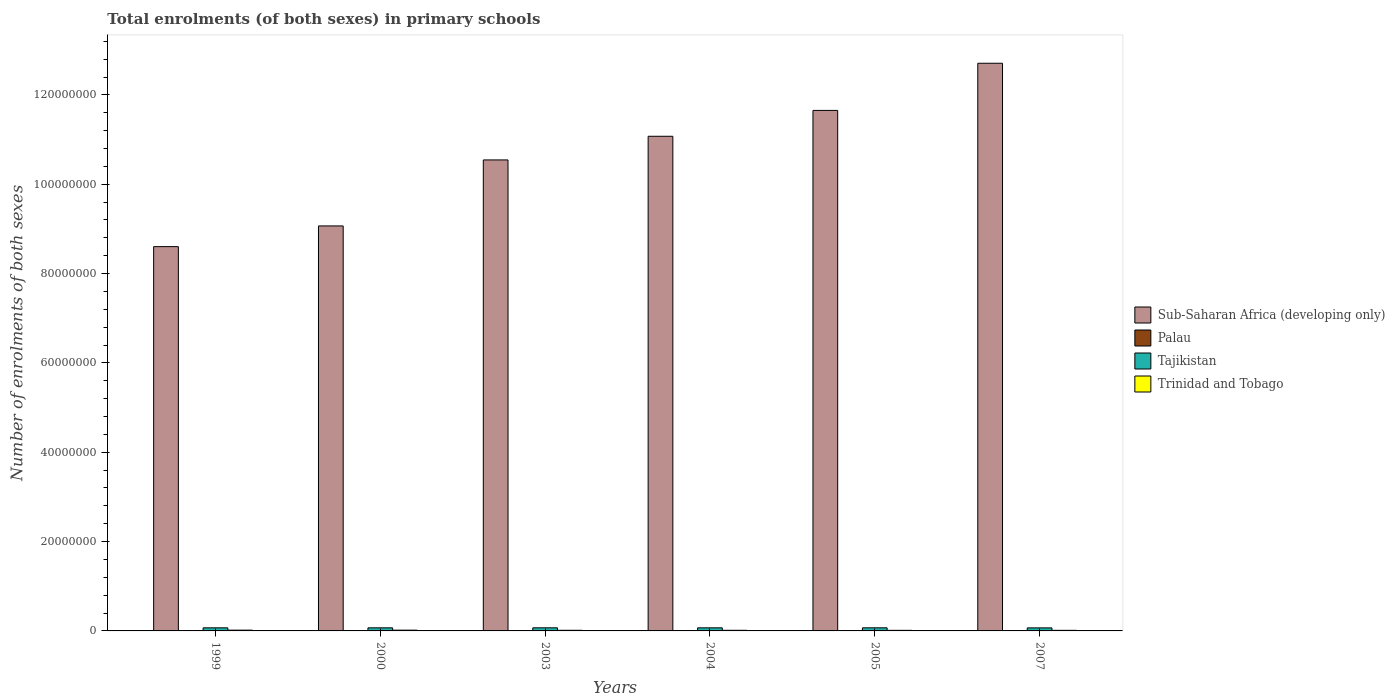How many groups of bars are there?
Provide a succinct answer. 6. Are the number of bars per tick equal to the number of legend labels?
Provide a succinct answer. Yes. Are the number of bars on each tick of the X-axis equal?
Provide a succinct answer. Yes. How many bars are there on the 5th tick from the left?
Provide a succinct answer. 4. What is the number of enrolments in primary schools in Sub-Saharan Africa (developing only) in 2005?
Offer a terse response. 1.17e+08. Across all years, what is the maximum number of enrolments in primary schools in Tajikistan?
Make the answer very short. 6.95e+05. Across all years, what is the minimum number of enrolments in primary schools in Tajikistan?
Provide a short and direct response. 6.80e+05. In which year was the number of enrolments in primary schools in Palau maximum?
Your answer should be very brief. 2003. In which year was the number of enrolments in primary schools in Trinidad and Tobago minimum?
Your answer should be compact. 2005. What is the total number of enrolments in primary schools in Sub-Saharan Africa (developing only) in the graph?
Your answer should be very brief. 6.36e+08. What is the difference between the number of enrolments in primary schools in Trinidad and Tobago in 2004 and that in 2005?
Give a very brief answer. 7610. What is the difference between the number of enrolments in primary schools in Palau in 2003 and the number of enrolments in primary schools in Tajikistan in 2004?
Provide a short and direct response. -6.88e+05. What is the average number of enrolments in primary schools in Sub-Saharan Africa (developing only) per year?
Your answer should be compact. 1.06e+08. In the year 2000, what is the difference between the number of enrolments in primary schools in Palau and number of enrolments in primary schools in Tajikistan?
Offer a very short reply. -6.90e+05. In how many years, is the number of enrolments in primary schools in Tajikistan greater than 68000000?
Ensure brevity in your answer.  0. What is the ratio of the number of enrolments in primary schools in Sub-Saharan Africa (developing only) in 2003 to that in 2007?
Your answer should be compact. 0.83. Is the difference between the number of enrolments in primary schools in Palau in 2004 and 2005 greater than the difference between the number of enrolments in primary schools in Tajikistan in 2004 and 2005?
Keep it short and to the point. Yes. What is the difference between the highest and the second highest number of enrolments in primary schools in Tajikistan?
Make the answer very short. 1852. What is the difference between the highest and the lowest number of enrolments in primary schools in Tajikistan?
Your answer should be very brief. 1.46e+04. Is it the case that in every year, the sum of the number of enrolments in primary schools in Sub-Saharan Africa (developing only) and number of enrolments in primary schools in Tajikistan is greater than the sum of number of enrolments in primary schools in Trinidad and Tobago and number of enrolments in primary schools in Palau?
Your answer should be compact. Yes. What does the 4th bar from the left in 2004 represents?
Ensure brevity in your answer.  Trinidad and Tobago. What does the 1st bar from the right in 2000 represents?
Your answer should be compact. Trinidad and Tobago. Is it the case that in every year, the sum of the number of enrolments in primary schools in Sub-Saharan Africa (developing only) and number of enrolments in primary schools in Palau is greater than the number of enrolments in primary schools in Tajikistan?
Ensure brevity in your answer.  Yes. How many years are there in the graph?
Keep it short and to the point. 6. What is the difference between two consecutive major ticks on the Y-axis?
Offer a terse response. 2.00e+07. Are the values on the major ticks of Y-axis written in scientific E-notation?
Give a very brief answer. No. Does the graph contain any zero values?
Ensure brevity in your answer.  No. Where does the legend appear in the graph?
Give a very brief answer. Center right. What is the title of the graph?
Ensure brevity in your answer.  Total enrolments (of both sexes) in primary schools. What is the label or title of the X-axis?
Your answer should be very brief. Years. What is the label or title of the Y-axis?
Provide a short and direct response. Number of enrolments of both sexes. What is the Number of enrolments of both sexes in Sub-Saharan Africa (developing only) in 1999?
Give a very brief answer. 8.60e+07. What is the Number of enrolments of both sexes in Palau in 1999?
Your answer should be compact. 1901. What is the Number of enrolments of both sexes in Tajikistan in 1999?
Give a very brief answer. 6.90e+05. What is the Number of enrolments of both sexes of Trinidad and Tobago in 1999?
Provide a succinct answer. 1.72e+05. What is the Number of enrolments of both sexes in Sub-Saharan Africa (developing only) in 2000?
Offer a terse response. 9.07e+07. What is the Number of enrolments of both sexes in Palau in 2000?
Your answer should be very brief. 1942. What is the Number of enrolments of both sexes of Tajikistan in 2000?
Your response must be concise. 6.92e+05. What is the Number of enrolments of both sexes in Trinidad and Tobago in 2000?
Your response must be concise. 1.69e+05. What is the Number of enrolments of both sexes in Sub-Saharan Africa (developing only) in 2003?
Your answer should be compact. 1.05e+08. What is the Number of enrolments of both sexes of Palau in 2003?
Provide a short and direct response. 1985. What is the Number of enrolments of both sexes in Tajikistan in 2003?
Offer a very short reply. 6.95e+05. What is the Number of enrolments of both sexes of Trinidad and Tobago in 2003?
Your answer should be compact. 1.41e+05. What is the Number of enrolments of both sexes in Sub-Saharan Africa (developing only) in 2004?
Provide a succinct answer. 1.11e+08. What is the Number of enrolments of both sexes in Palau in 2004?
Give a very brief answer. 1855. What is the Number of enrolments of both sexes in Tajikistan in 2004?
Your answer should be very brief. 6.90e+05. What is the Number of enrolments of both sexes in Trinidad and Tobago in 2004?
Offer a very short reply. 1.37e+05. What is the Number of enrolments of both sexes of Sub-Saharan Africa (developing only) in 2005?
Your answer should be compact. 1.17e+08. What is the Number of enrolments of both sexes of Palau in 2005?
Keep it short and to the point. 1805. What is the Number of enrolments of both sexes of Tajikistan in 2005?
Provide a succinct answer. 6.93e+05. What is the Number of enrolments of both sexes in Trinidad and Tobago in 2005?
Keep it short and to the point. 1.30e+05. What is the Number of enrolments of both sexes in Sub-Saharan Africa (developing only) in 2007?
Provide a succinct answer. 1.27e+08. What is the Number of enrolments of both sexes in Palau in 2007?
Keep it short and to the point. 1544. What is the Number of enrolments of both sexes in Tajikistan in 2007?
Offer a very short reply. 6.80e+05. What is the Number of enrolments of both sexes of Trinidad and Tobago in 2007?
Give a very brief answer. 1.30e+05. Across all years, what is the maximum Number of enrolments of both sexes in Sub-Saharan Africa (developing only)?
Your answer should be compact. 1.27e+08. Across all years, what is the maximum Number of enrolments of both sexes in Palau?
Provide a succinct answer. 1985. Across all years, what is the maximum Number of enrolments of both sexes of Tajikistan?
Make the answer very short. 6.95e+05. Across all years, what is the maximum Number of enrolments of both sexes of Trinidad and Tobago?
Give a very brief answer. 1.72e+05. Across all years, what is the minimum Number of enrolments of both sexes in Sub-Saharan Africa (developing only)?
Your response must be concise. 8.60e+07. Across all years, what is the minimum Number of enrolments of both sexes in Palau?
Your response must be concise. 1544. Across all years, what is the minimum Number of enrolments of both sexes in Tajikistan?
Make the answer very short. 6.80e+05. Across all years, what is the minimum Number of enrolments of both sexes in Trinidad and Tobago?
Your answer should be very brief. 1.30e+05. What is the total Number of enrolments of both sexes in Sub-Saharan Africa (developing only) in the graph?
Offer a very short reply. 6.36e+08. What is the total Number of enrolments of both sexes in Palau in the graph?
Offer a very short reply. 1.10e+04. What is the total Number of enrolments of both sexes of Tajikistan in the graph?
Give a very brief answer. 4.14e+06. What is the total Number of enrolments of both sexes in Trinidad and Tobago in the graph?
Ensure brevity in your answer.  8.79e+05. What is the difference between the Number of enrolments of both sexes of Sub-Saharan Africa (developing only) in 1999 and that in 2000?
Make the answer very short. -4.64e+06. What is the difference between the Number of enrolments of both sexes of Palau in 1999 and that in 2000?
Provide a succinct answer. -41. What is the difference between the Number of enrolments of both sexes of Tajikistan in 1999 and that in 2000?
Ensure brevity in your answer.  -1585. What is the difference between the Number of enrolments of both sexes in Trinidad and Tobago in 1999 and that in 2000?
Provide a short and direct response. 3672. What is the difference between the Number of enrolments of both sexes of Sub-Saharan Africa (developing only) in 1999 and that in 2003?
Make the answer very short. -1.94e+07. What is the difference between the Number of enrolments of both sexes in Palau in 1999 and that in 2003?
Make the answer very short. -84. What is the difference between the Number of enrolments of both sexes in Tajikistan in 1999 and that in 2003?
Provide a short and direct response. -4624. What is the difference between the Number of enrolments of both sexes of Trinidad and Tobago in 1999 and that in 2003?
Give a very brief answer. 3.12e+04. What is the difference between the Number of enrolments of both sexes in Sub-Saharan Africa (developing only) in 1999 and that in 2004?
Ensure brevity in your answer.  -2.47e+07. What is the difference between the Number of enrolments of both sexes in Palau in 1999 and that in 2004?
Provide a succinct answer. 46. What is the difference between the Number of enrolments of both sexes of Trinidad and Tobago in 1999 and that in 2004?
Your response must be concise. 3.49e+04. What is the difference between the Number of enrolments of both sexes in Sub-Saharan Africa (developing only) in 1999 and that in 2005?
Provide a succinct answer. -3.05e+07. What is the difference between the Number of enrolments of both sexes in Palau in 1999 and that in 2005?
Keep it short and to the point. 96. What is the difference between the Number of enrolments of both sexes of Tajikistan in 1999 and that in 2005?
Offer a terse response. -2772. What is the difference between the Number of enrolments of both sexes in Trinidad and Tobago in 1999 and that in 2005?
Offer a very short reply. 4.25e+04. What is the difference between the Number of enrolments of both sexes of Sub-Saharan Africa (developing only) in 1999 and that in 2007?
Keep it short and to the point. -4.11e+07. What is the difference between the Number of enrolments of both sexes in Palau in 1999 and that in 2007?
Give a very brief answer. 357. What is the difference between the Number of enrolments of both sexes in Tajikistan in 1999 and that in 2007?
Provide a succinct answer. 9998. What is the difference between the Number of enrolments of both sexes of Trinidad and Tobago in 1999 and that in 2007?
Ensure brevity in your answer.  4.20e+04. What is the difference between the Number of enrolments of both sexes in Sub-Saharan Africa (developing only) in 2000 and that in 2003?
Make the answer very short. -1.48e+07. What is the difference between the Number of enrolments of both sexes in Palau in 2000 and that in 2003?
Offer a very short reply. -43. What is the difference between the Number of enrolments of both sexes of Tajikistan in 2000 and that in 2003?
Provide a short and direct response. -3039. What is the difference between the Number of enrolments of both sexes of Trinidad and Tobago in 2000 and that in 2003?
Keep it short and to the point. 2.75e+04. What is the difference between the Number of enrolments of both sexes in Sub-Saharan Africa (developing only) in 2000 and that in 2004?
Make the answer very short. -2.01e+07. What is the difference between the Number of enrolments of both sexes in Tajikistan in 2000 and that in 2004?
Provide a short and direct response. 1621. What is the difference between the Number of enrolments of both sexes of Trinidad and Tobago in 2000 and that in 2004?
Your answer should be compact. 3.12e+04. What is the difference between the Number of enrolments of both sexes in Sub-Saharan Africa (developing only) in 2000 and that in 2005?
Your answer should be compact. -2.59e+07. What is the difference between the Number of enrolments of both sexes in Palau in 2000 and that in 2005?
Provide a short and direct response. 137. What is the difference between the Number of enrolments of both sexes in Tajikistan in 2000 and that in 2005?
Provide a short and direct response. -1187. What is the difference between the Number of enrolments of both sexes in Trinidad and Tobago in 2000 and that in 2005?
Your response must be concise. 3.88e+04. What is the difference between the Number of enrolments of both sexes of Sub-Saharan Africa (developing only) in 2000 and that in 2007?
Provide a short and direct response. -3.64e+07. What is the difference between the Number of enrolments of both sexes of Palau in 2000 and that in 2007?
Your answer should be very brief. 398. What is the difference between the Number of enrolments of both sexes in Tajikistan in 2000 and that in 2007?
Provide a succinct answer. 1.16e+04. What is the difference between the Number of enrolments of both sexes of Trinidad and Tobago in 2000 and that in 2007?
Offer a very short reply. 3.83e+04. What is the difference between the Number of enrolments of both sexes of Sub-Saharan Africa (developing only) in 2003 and that in 2004?
Your response must be concise. -5.30e+06. What is the difference between the Number of enrolments of both sexes of Palau in 2003 and that in 2004?
Keep it short and to the point. 130. What is the difference between the Number of enrolments of both sexes of Tajikistan in 2003 and that in 2004?
Make the answer very short. 4660. What is the difference between the Number of enrolments of both sexes in Trinidad and Tobago in 2003 and that in 2004?
Your answer should be very brief. 3723. What is the difference between the Number of enrolments of both sexes in Sub-Saharan Africa (developing only) in 2003 and that in 2005?
Keep it short and to the point. -1.11e+07. What is the difference between the Number of enrolments of both sexes in Palau in 2003 and that in 2005?
Provide a short and direct response. 180. What is the difference between the Number of enrolments of both sexes of Tajikistan in 2003 and that in 2005?
Keep it short and to the point. 1852. What is the difference between the Number of enrolments of both sexes of Trinidad and Tobago in 2003 and that in 2005?
Offer a terse response. 1.13e+04. What is the difference between the Number of enrolments of both sexes in Sub-Saharan Africa (developing only) in 2003 and that in 2007?
Keep it short and to the point. -2.16e+07. What is the difference between the Number of enrolments of both sexes of Palau in 2003 and that in 2007?
Ensure brevity in your answer.  441. What is the difference between the Number of enrolments of both sexes in Tajikistan in 2003 and that in 2007?
Keep it short and to the point. 1.46e+04. What is the difference between the Number of enrolments of both sexes of Trinidad and Tobago in 2003 and that in 2007?
Provide a short and direct response. 1.08e+04. What is the difference between the Number of enrolments of both sexes of Sub-Saharan Africa (developing only) in 2004 and that in 2005?
Your answer should be compact. -5.79e+06. What is the difference between the Number of enrolments of both sexes in Palau in 2004 and that in 2005?
Provide a short and direct response. 50. What is the difference between the Number of enrolments of both sexes in Tajikistan in 2004 and that in 2005?
Give a very brief answer. -2808. What is the difference between the Number of enrolments of both sexes in Trinidad and Tobago in 2004 and that in 2005?
Offer a very short reply. 7610. What is the difference between the Number of enrolments of both sexes of Sub-Saharan Africa (developing only) in 2004 and that in 2007?
Make the answer very short. -1.63e+07. What is the difference between the Number of enrolments of both sexes in Palau in 2004 and that in 2007?
Keep it short and to the point. 311. What is the difference between the Number of enrolments of both sexes of Tajikistan in 2004 and that in 2007?
Provide a succinct answer. 9962. What is the difference between the Number of enrolments of both sexes of Trinidad and Tobago in 2004 and that in 2007?
Make the answer very short. 7071. What is the difference between the Number of enrolments of both sexes in Sub-Saharan Africa (developing only) in 2005 and that in 2007?
Make the answer very short. -1.06e+07. What is the difference between the Number of enrolments of both sexes in Palau in 2005 and that in 2007?
Provide a short and direct response. 261. What is the difference between the Number of enrolments of both sexes in Tajikistan in 2005 and that in 2007?
Give a very brief answer. 1.28e+04. What is the difference between the Number of enrolments of both sexes in Trinidad and Tobago in 2005 and that in 2007?
Your response must be concise. -539. What is the difference between the Number of enrolments of both sexes in Sub-Saharan Africa (developing only) in 1999 and the Number of enrolments of both sexes in Palau in 2000?
Your response must be concise. 8.60e+07. What is the difference between the Number of enrolments of both sexes in Sub-Saharan Africa (developing only) in 1999 and the Number of enrolments of both sexes in Tajikistan in 2000?
Keep it short and to the point. 8.53e+07. What is the difference between the Number of enrolments of both sexes of Sub-Saharan Africa (developing only) in 1999 and the Number of enrolments of both sexes of Trinidad and Tobago in 2000?
Ensure brevity in your answer.  8.59e+07. What is the difference between the Number of enrolments of both sexes of Palau in 1999 and the Number of enrolments of both sexes of Tajikistan in 2000?
Provide a succinct answer. -6.90e+05. What is the difference between the Number of enrolments of both sexes of Palau in 1999 and the Number of enrolments of both sexes of Trinidad and Tobago in 2000?
Make the answer very short. -1.67e+05. What is the difference between the Number of enrolments of both sexes in Tajikistan in 1999 and the Number of enrolments of both sexes in Trinidad and Tobago in 2000?
Your answer should be compact. 5.22e+05. What is the difference between the Number of enrolments of both sexes in Sub-Saharan Africa (developing only) in 1999 and the Number of enrolments of both sexes in Palau in 2003?
Your answer should be compact. 8.60e+07. What is the difference between the Number of enrolments of both sexes of Sub-Saharan Africa (developing only) in 1999 and the Number of enrolments of both sexes of Tajikistan in 2003?
Give a very brief answer. 8.53e+07. What is the difference between the Number of enrolments of both sexes in Sub-Saharan Africa (developing only) in 1999 and the Number of enrolments of both sexes in Trinidad and Tobago in 2003?
Your answer should be very brief. 8.59e+07. What is the difference between the Number of enrolments of both sexes of Palau in 1999 and the Number of enrolments of both sexes of Tajikistan in 2003?
Your response must be concise. -6.93e+05. What is the difference between the Number of enrolments of both sexes of Palau in 1999 and the Number of enrolments of both sexes of Trinidad and Tobago in 2003?
Offer a very short reply. -1.39e+05. What is the difference between the Number of enrolments of both sexes in Tajikistan in 1999 and the Number of enrolments of both sexes in Trinidad and Tobago in 2003?
Provide a short and direct response. 5.49e+05. What is the difference between the Number of enrolments of both sexes in Sub-Saharan Africa (developing only) in 1999 and the Number of enrolments of both sexes in Palau in 2004?
Offer a terse response. 8.60e+07. What is the difference between the Number of enrolments of both sexes in Sub-Saharan Africa (developing only) in 1999 and the Number of enrolments of both sexes in Tajikistan in 2004?
Ensure brevity in your answer.  8.53e+07. What is the difference between the Number of enrolments of both sexes in Sub-Saharan Africa (developing only) in 1999 and the Number of enrolments of both sexes in Trinidad and Tobago in 2004?
Ensure brevity in your answer.  8.59e+07. What is the difference between the Number of enrolments of both sexes in Palau in 1999 and the Number of enrolments of both sexes in Tajikistan in 2004?
Keep it short and to the point. -6.88e+05. What is the difference between the Number of enrolments of both sexes in Palau in 1999 and the Number of enrolments of both sexes in Trinidad and Tobago in 2004?
Give a very brief answer. -1.35e+05. What is the difference between the Number of enrolments of both sexes in Tajikistan in 1999 and the Number of enrolments of both sexes in Trinidad and Tobago in 2004?
Keep it short and to the point. 5.53e+05. What is the difference between the Number of enrolments of both sexes of Sub-Saharan Africa (developing only) in 1999 and the Number of enrolments of both sexes of Palau in 2005?
Offer a very short reply. 8.60e+07. What is the difference between the Number of enrolments of both sexes of Sub-Saharan Africa (developing only) in 1999 and the Number of enrolments of both sexes of Tajikistan in 2005?
Provide a short and direct response. 8.53e+07. What is the difference between the Number of enrolments of both sexes of Sub-Saharan Africa (developing only) in 1999 and the Number of enrolments of both sexes of Trinidad and Tobago in 2005?
Your response must be concise. 8.59e+07. What is the difference between the Number of enrolments of both sexes in Palau in 1999 and the Number of enrolments of both sexes in Tajikistan in 2005?
Offer a terse response. -6.91e+05. What is the difference between the Number of enrolments of both sexes in Palau in 1999 and the Number of enrolments of both sexes in Trinidad and Tobago in 2005?
Provide a succinct answer. -1.28e+05. What is the difference between the Number of enrolments of both sexes of Tajikistan in 1999 and the Number of enrolments of both sexes of Trinidad and Tobago in 2005?
Offer a terse response. 5.61e+05. What is the difference between the Number of enrolments of both sexes of Sub-Saharan Africa (developing only) in 1999 and the Number of enrolments of both sexes of Palau in 2007?
Your answer should be very brief. 8.60e+07. What is the difference between the Number of enrolments of both sexes in Sub-Saharan Africa (developing only) in 1999 and the Number of enrolments of both sexes in Tajikistan in 2007?
Your answer should be compact. 8.53e+07. What is the difference between the Number of enrolments of both sexes in Sub-Saharan Africa (developing only) in 1999 and the Number of enrolments of both sexes in Trinidad and Tobago in 2007?
Keep it short and to the point. 8.59e+07. What is the difference between the Number of enrolments of both sexes in Palau in 1999 and the Number of enrolments of both sexes in Tajikistan in 2007?
Offer a terse response. -6.78e+05. What is the difference between the Number of enrolments of both sexes of Palau in 1999 and the Number of enrolments of both sexes of Trinidad and Tobago in 2007?
Provide a succinct answer. -1.28e+05. What is the difference between the Number of enrolments of both sexes of Tajikistan in 1999 and the Number of enrolments of both sexes of Trinidad and Tobago in 2007?
Keep it short and to the point. 5.60e+05. What is the difference between the Number of enrolments of both sexes in Sub-Saharan Africa (developing only) in 2000 and the Number of enrolments of both sexes in Palau in 2003?
Ensure brevity in your answer.  9.07e+07. What is the difference between the Number of enrolments of both sexes in Sub-Saharan Africa (developing only) in 2000 and the Number of enrolments of both sexes in Tajikistan in 2003?
Keep it short and to the point. 9.00e+07. What is the difference between the Number of enrolments of both sexes in Sub-Saharan Africa (developing only) in 2000 and the Number of enrolments of both sexes in Trinidad and Tobago in 2003?
Offer a terse response. 9.05e+07. What is the difference between the Number of enrolments of both sexes in Palau in 2000 and the Number of enrolments of both sexes in Tajikistan in 2003?
Offer a terse response. -6.93e+05. What is the difference between the Number of enrolments of both sexes in Palau in 2000 and the Number of enrolments of both sexes in Trinidad and Tobago in 2003?
Provide a short and direct response. -1.39e+05. What is the difference between the Number of enrolments of both sexes of Tajikistan in 2000 and the Number of enrolments of both sexes of Trinidad and Tobago in 2003?
Your response must be concise. 5.51e+05. What is the difference between the Number of enrolments of both sexes of Sub-Saharan Africa (developing only) in 2000 and the Number of enrolments of both sexes of Palau in 2004?
Provide a short and direct response. 9.07e+07. What is the difference between the Number of enrolments of both sexes of Sub-Saharan Africa (developing only) in 2000 and the Number of enrolments of both sexes of Tajikistan in 2004?
Ensure brevity in your answer.  9.00e+07. What is the difference between the Number of enrolments of both sexes in Sub-Saharan Africa (developing only) in 2000 and the Number of enrolments of both sexes in Trinidad and Tobago in 2004?
Provide a succinct answer. 9.05e+07. What is the difference between the Number of enrolments of both sexes in Palau in 2000 and the Number of enrolments of both sexes in Tajikistan in 2004?
Provide a succinct answer. -6.88e+05. What is the difference between the Number of enrolments of both sexes of Palau in 2000 and the Number of enrolments of both sexes of Trinidad and Tobago in 2004?
Offer a very short reply. -1.35e+05. What is the difference between the Number of enrolments of both sexes of Tajikistan in 2000 and the Number of enrolments of both sexes of Trinidad and Tobago in 2004?
Provide a short and direct response. 5.55e+05. What is the difference between the Number of enrolments of both sexes of Sub-Saharan Africa (developing only) in 2000 and the Number of enrolments of both sexes of Palau in 2005?
Offer a terse response. 9.07e+07. What is the difference between the Number of enrolments of both sexes of Sub-Saharan Africa (developing only) in 2000 and the Number of enrolments of both sexes of Tajikistan in 2005?
Make the answer very short. 9.00e+07. What is the difference between the Number of enrolments of both sexes of Sub-Saharan Africa (developing only) in 2000 and the Number of enrolments of both sexes of Trinidad and Tobago in 2005?
Your response must be concise. 9.05e+07. What is the difference between the Number of enrolments of both sexes of Palau in 2000 and the Number of enrolments of both sexes of Tajikistan in 2005?
Offer a terse response. -6.91e+05. What is the difference between the Number of enrolments of both sexes in Palau in 2000 and the Number of enrolments of both sexes in Trinidad and Tobago in 2005?
Your answer should be very brief. -1.28e+05. What is the difference between the Number of enrolments of both sexes in Tajikistan in 2000 and the Number of enrolments of both sexes in Trinidad and Tobago in 2005?
Offer a very short reply. 5.62e+05. What is the difference between the Number of enrolments of both sexes of Sub-Saharan Africa (developing only) in 2000 and the Number of enrolments of both sexes of Palau in 2007?
Keep it short and to the point. 9.07e+07. What is the difference between the Number of enrolments of both sexes in Sub-Saharan Africa (developing only) in 2000 and the Number of enrolments of both sexes in Tajikistan in 2007?
Your response must be concise. 9.00e+07. What is the difference between the Number of enrolments of both sexes in Sub-Saharan Africa (developing only) in 2000 and the Number of enrolments of both sexes in Trinidad and Tobago in 2007?
Your answer should be very brief. 9.05e+07. What is the difference between the Number of enrolments of both sexes in Palau in 2000 and the Number of enrolments of both sexes in Tajikistan in 2007?
Offer a terse response. -6.78e+05. What is the difference between the Number of enrolments of both sexes of Palau in 2000 and the Number of enrolments of both sexes of Trinidad and Tobago in 2007?
Keep it short and to the point. -1.28e+05. What is the difference between the Number of enrolments of both sexes in Tajikistan in 2000 and the Number of enrolments of both sexes in Trinidad and Tobago in 2007?
Keep it short and to the point. 5.62e+05. What is the difference between the Number of enrolments of both sexes of Sub-Saharan Africa (developing only) in 2003 and the Number of enrolments of both sexes of Palau in 2004?
Provide a short and direct response. 1.05e+08. What is the difference between the Number of enrolments of both sexes of Sub-Saharan Africa (developing only) in 2003 and the Number of enrolments of both sexes of Tajikistan in 2004?
Keep it short and to the point. 1.05e+08. What is the difference between the Number of enrolments of both sexes in Sub-Saharan Africa (developing only) in 2003 and the Number of enrolments of both sexes in Trinidad and Tobago in 2004?
Give a very brief answer. 1.05e+08. What is the difference between the Number of enrolments of both sexes of Palau in 2003 and the Number of enrolments of both sexes of Tajikistan in 2004?
Your answer should be compact. -6.88e+05. What is the difference between the Number of enrolments of both sexes in Palau in 2003 and the Number of enrolments of both sexes in Trinidad and Tobago in 2004?
Provide a short and direct response. -1.35e+05. What is the difference between the Number of enrolments of both sexes of Tajikistan in 2003 and the Number of enrolments of both sexes of Trinidad and Tobago in 2004?
Make the answer very short. 5.58e+05. What is the difference between the Number of enrolments of both sexes of Sub-Saharan Africa (developing only) in 2003 and the Number of enrolments of both sexes of Palau in 2005?
Give a very brief answer. 1.05e+08. What is the difference between the Number of enrolments of both sexes of Sub-Saharan Africa (developing only) in 2003 and the Number of enrolments of both sexes of Tajikistan in 2005?
Provide a succinct answer. 1.05e+08. What is the difference between the Number of enrolments of both sexes of Sub-Saharan Africa (developing only) in 2003 and the Number of enrolments of both sexes of Trinidad and Tobago in 2005?
Make the answer very short. 1.05e+08. What is the difference between the Number of enrolments of both sexes of Palau in 2003 and the Number of enrolments of both sexes of Tajikistan in 2005?
Ensure brevity in your answer.  -6.91e+05. What is the difference between the Number of enrolments of both sexes in Palau in 2003 and the Number of enrolments of both sexes in Trinidad and Tobago in 2005?
Your answer should be compact. -1.28e+05. What is the difference between the Number of enrolments of both sexes in Tajikistan in 2003 and the Number of enrolments of both sexes in Trinidad and Tobago in 2005?
Make the answer very short. 5.65e+05. What is the difference between the Number of enrolments of both sexes in Sub-Saharan Africa (developing only) in 2003 and the Number of enrolments of both sexes in Palau in 2007?
Your answer should be very brief. 1.05e+08. What is the difference between the Number of enrolments of both sexes in Sub-Saharan Africa (developing only) in 2003 and the Number of enrolments of both sexes in Tajikistan in 2007?
Keep it short and to the point. 1.05e+08. What is the difference between the Number of enrolments of both sexes of Sub-Saharan Africa (developing only) in 2003 and the Number of enrolments of both sexes of Trinidad and Tobago in 2007?
Give a very brief answer. 1.05e+08. What is the difference between the Number of enrolments of both sexes of Palau in 2003 and the Number of enrolments of both sexes of Tajikistan in 2007?
Give a very brief answer. -6.78e+05. What is the difference between the Number of enrolments of both sexes of Palau in 2003 and the Number of enrolments of both sexes of Trinidad and Tobago in 2007?
Make the answer very short. -1.28e+05. What is the difference between the Number of enrolments of both sexes of Tajikistan in 2003 and the Number of enrolments of both sexes of Trinidad and Tobago in 2007?
Your response must be concise. 5.65e+05. What is the difference between the Number of enrolments of both sexes of Sub-Saharan Africa (developing only) in 2004 and the Number of enrolments of both sexes of Palau in 2005?
Your response must be concise. 1.11e+08. What is the difference between the Number of enrolments of both sexes in Sub-Saharan Africa (developing only) in 2004 and the Number of enrolments of both sexes in Tajikistan in 2005?
Offer a very short reply. 1.10e+08. What is the difference between the Number of enrolments of both sexes of Sub-Saharan Africa (developing only) in 2004 and the Number of enrolments of both sexes of Trinidad and Tobago in 2005?
Keep it short and to the point. 1.11e+08. What is the difference between the Number of enrolments of both sexes of Palau in 2004 and the Number of enrolments of both sexes of Tajikistan in 2005?
Your answer should be compact. -6.91e+05. What is the difference between the Number of enrolments of both sexes in Palau in 2004 and the Number of enrolments of both sexes in Trinidad and Tobago in 2005?
Give a very brief answer. -1.28e+05. What is the difference between the Number of enrolments of both sexes of Tajikistan in 2004 and the Number of enrolments of both sexes of Trinidad and Tobago in 2005?
Your response must be concise. 5.61e+05. What is the difference between the Number of enrolments of both sexes in Sub-Saharan Africa (developing only) in 2004 and the Number of enrolments of both sexes in Palau in 2007?
Your answer should be compact. 1.11e+08. What is the difference between the Number of enrolments of both sexes of Sub-Saharan Africa (developing only) in 2004 and the Number of enrolments of both sexes of Tajikistan in 2007?
Offer a terse response. 1.10e+08. What is the difference between the Number of enrolments of both sexes of Sub-Saharan Africa (developing only) in 2004 and the Number of enrolments of both sexes of Trinidad and Tobago in 2007?
Provide a succinct answer. 1.11e+08. What is the difference between the Number of enrolments of both sexes in Palau in 2004 and the Number of enrolments of both sexes in Tajikistan in 2007?
Provide a short and direct response. -6.78e+05. What is the difference between the Number of enrolments of both sexes in Palau in 2004 and the Number of enrolments of both sexes in Trinidad and Tobago in 2007?
Ensure brevity in your answer.  -1.28e+05. What is the difference between the Number of enrolments of both sexes in Tajikistan in 2004 and the Number of enrolments of both sexes in Trinidad and Tobago in 2007?
Ensure brevity in your answer.  5.60e+05. What is the difference between the Number of enrolments of both sexes of Sub-Saharan Africa (developing only) in 2005 and the Number of enrolments of both sexes of Palau in 2007?
Your response must be concise. 1.17e+08. What is the difference between the Number of enrolments of both sexes in Sub-Saharan Africa (developing only) in 2005 and the Number of enrolments of both sexes in Tajikistan in 2007?
Ensure brevity in your answer.  1.16e+08. What is the difference between the Number of enrolments of both sexes in Sub-Saharan Africa (developing only) in 2005 and the Number of enrolments of both sexes in Trinidad and Tobago in 2007?
Provide a succinct answer. 1.16e+08. What is the difference between the Number of enrolments of both sexes of Palau in 2005 and the Number of enrolments of both sexes of Tajikistan in 2007?
Offer a terse response. -6.79e+05. What is the difference between the Number of enrolments of both sexes of Palau in 2005 and the Number of enrolments of both sexes of Trinidad and Tobago in 2007?
Keep it short and to the point. -1.28e+05. What is the difference between the Number of enrolments of both sexes in Tajikistan in 2005 and the Number of enrolments of both sexes in Trinidad and Tobago in 2007?
Your answer should be very brief. 5.63e+05. What is the average Number of enrolments of both sexes in Sub-Saharan Africa (developing only) per year?
Give a very brief answer. 1.06e+08. What is the average Number of enrolments of both sexes in Palau per year?
Provide a short and direct response. 1838.67. What is the average Number of enrolments of both sexes in Tajikistan per year?
Provide a succinct answer. 6.90e+05. What is the average Number of enrolments of both sexes in Trinidad and Tobago per year?
Provide a succinct answer. 1.47e+05. In the year 1999, what is the difference between the Number of enrolments of both sexes of Sub-Saharan Africa (developing only) and Number of enrolments of both sexes of Palau?
Provide a short and direct response. 8.60e+07. In the year 1999, what is the difference between the Number of enrolments of both sexes in Sub-Saharan Africa (developing only) and Number of enrolments of both sexes in Tajikistan?
Your response must be concise. 8.53e+07. In the year 1999, what is the difference between the Number of enrolments of both sexes of Sub-Saharan Africa (developing only) and Number of enrolments of both sexes of Trinidad and Tobago?
Offer a very short reply. 8.59e+07. In the year 1999, what is the difference between the Number of enrolments of both sexes of Palau and Number of enrolments of both sexes of Tajikistan?
Your answer should be very brief. -6.88e+05. In the year 1999, what is the difference between the Number of enrolments of both sexes of Palau and Number of enrolments of both sexes of Trinidad and Tobago?
Make the answer very short. -1.70e+05. In the year 1999, what is the difference between the Number of enrolments of both sexes of Tajikistan and Number of enrolments of both sexes of Trinidad and Tobago?
Your response must be concise. 5.18e+05. In the year 2000, what is the difference between the Number of enrolments of both sexes of Sub-Saharan Africa (developing only) and Number of enrolments of both sexes of Palau?
Your answer should be compact. 9.07e+07. In the year 2000, what is the difference between the Number of enrolments of both sexes of Sub-Saharan Africa (developing only) and Number of enrolments of both sexes of Tajikistan?
Keep it short and to the point. 9.00e+07. In the year 2000, what is the difference between the Number of enrolments of both sexes in Sub-Saharan Africa (developing only) and Number of enrolments of both sexes in Trinidad and Tobago?
Your answer should be very brief. 9.05e+07. In the year 2000, what is the difference between the Number of enrolments of both sexes of Palau and Number of enrolments of both sexes of Tajikistan?
Make the answer very short. -6.90e+05. In the year 2000, what is the difference between the Number of enrolments of both sexes in Palau and Number of enrolments of both sexes in Trinidad and Tobago?
Ensure brevity in your answer.  -1.67e+05. In the year 2000, what is the difference between the Number of enrolments of both sexes in Tajikistan and Number of enrolments of both sexes in Trinidad and Tobago?
Keep it short and to the point. 5.23e+05. In the year 2003, what is the difference between the Number of enrolments of both sexes of Sub-Saharan Africa (developing only) and Number of enrolments of both sexes of Palau?
Your answer should be compact. 1.05e+08. In the year 2003, what is the difference between the Number of enrolments of both sexes of Sub-Saharan Africa (developing only) and Number of enrolments of both sexes of Tajikistan?
Offer a very short reply. 1.05e+08. In the year 2003, what is the difference between the Number of enrolments of both sexes of Sub-Saharan Africa (developing only) and Number of enrolments of both sexes of Trinidad and Tobago?
Offer a very short reply. 1.05e+08. In the year 2003, what is the difference between the Number of enrolments of both sexes in Palau and Number of enrolments of both sexes in Tajikistan?
Ensure brevity in your answer.  -6.93e+05. In the year 2003, what is the difference between the Number of enrolments of both sexes of Palau and Number of enrolments of both sexes of Trinidad and Tobago?
Offer a very short reply. -1.39e+05. In the year 2003, what is the difference between the Number of enrolments of both sexes of Tajikistan and Number of enrolments of both sexes of Trinidad and Tobago?
Offer a very short reply. 5.54e+05. In the year 2004, what is the difference between the Number of enrolments of both sexes in Sub-Saharan Africa (developing only) and Number of enrolments of both sexes in Palau?
Your answer should be very brief. 1.11e+08. In the year 2004, what is the difference between the Number of enrolments of both sexes in Sub-Saharan Africa (developing only) and Number of enrolments of both sexes in Tajikistan?
Your response must be concise. 1.10e+08. In the year 2004, what is the difference between the Number of enrolments of both sexes in Sub-Saharan Africa (developing only) and Number of enrolments of both sexes in Trinidad and Tobago?
Offer a terse response. 1.11e+08. In the year 2004, what is the difference between the Number of enrolments of both sexes in Palau and Number of enrolments of both sexes in Tajikistan?
Offer a terse response. -6.88e+05. In the year 2004, what is the difference between the Number of enrolments of both sexes in Palau and Number of enrolments of both sexes in Trinidad and Tobago?
Provide a succinct answer. -1.35e+05. In the year 2004, what is the difference between the Number of enrolments of both sexes of Tajikistan and Number of enrolments of both sexes of Trinidad and Tobago?
Ensure brevity in your answer.  5.53e+05. In the year 2005, what is the difference between the Number of enrolments of both sexes in Sub-Saharan Africa (developing only) and Number of enrolments of both sexes in Palau?
Keep it short and to the point. 1.17e+08. In the year 2005, what is the difference between the Number of enrolments of both sexes in Sub-Saharan Africa (developing only) and Number of enrolments of both sexes in Tajikistan?
Your answer should be compact. 1.16e+08. In the year 2005, what is the difference between the Number of enrolments of both sexes of Sub-Saharan Africa (developing only) and Number of enrolments of both sexes of Trinidad and Tobago?
Offer a very short reply. 1.16e+08. In the year 2005, what is the difference between the Number of enrolments of both sexes of Palau and Number of enrolments of both sexes of Tajikistan?
Offer a very short reply. -6.91e+05. In the year 2005, what is the difference between the Number of enrolments of both sexes in Palau and Number of enrolments of both sexes in Trinidad and Tobago?
Offer a very short reply. -1.28e+05. In the year 2005, what is the difference between the Number of enrolments of both sexes in Tajikistan and Number of enrolments of both sexes in Trinidad and Tobago?
Offer a terse response. 5.63e+05. In the year 2007, what is the difference between the Number of enrolments of both sexes of Sub-Saharan Africa (developing only) and Number of enrolments of both sexes of Palau?
Ensure brevity in your answer.  1.27e+08. In the year 2007, what is the difference between the Number of enrolments of both sexes in Sub-Saharan Africa (developing only) and Number of enrolments of both sexes in Tajikistan?
Your answer should be very brief. 1.26e+08. In the year 2007, what is the difference between the Number of enrolments of both sexes of Sub-Saharan Africa (developing only) and Number of enrolments of both sexes of Trinidad and Tobago?
Give a very brief answer. 1.27e+08. In the year 2007, what is the difference between the Number of enrolments of both sexes in Palau and Number of enrolments of both sexes in Tajikistan?
Your answer should be compact. -6.79e+05. In the year 2007, what is the difference between the Number of enrolments of both sexes in Palau and Number of enrolments of both sexes in Trinidad and Tobago?
Provide a succinct answer. -1.29e+05. In the year 2007, what is the difference between the Number of enrolments of both sexes in Tajikistan and Number of enrolments of both sexes in Trinidad and Tobago?
Your response must be concise. 5.50e+05. What is the ratio of the Number of enrolments of both sexes of Sub-Saharan Africa (developing only) in 1999 to that in 2000?
Offer a terse response. 0.95. What is the ratio of the Number of enrolments of both sexes of Palau in 1999 to that in 2000?
Your answer should be very brief. 0.98. What is the ratio of the Number of enrolments of both sexes of Tajikistan in 1999 to that in 2000?
Your answer should be compact. 1. What is the ratio of the Number of enrolments of both sexes in Trinidad and Tobago in 1999 to that in 2000?
Your answer should be very brief. 1.02. What is the ratio of the Number of enrolments of both sexes of Sub-Saharan Africa (developing only) in 1999 to that in 2003?
Provide a succinct answer. 0.82. What is the ratio of the Number of enrolments of both sexes of Palau in 1999 to that in 2003?
Your response must be concise. 0.96. What is the ratio of the Number of enrolments of both sexes in Trinidad and Tobago in 1999 to that in 2003?
Make the answer very short. 1.22. What is the ratio of the Number of enrolments of both sexes in Sub-Saharan Africa (developing only) in 1999 to that in 2004?
Ensure brevity in your answer.  0.78. What is the ratio of the Number of enrolments of both sexes of Palau in 1999 to that in 2004?
Your answer should be compact. 1.02. What is the ratio of the Number of enrolments of both sexes of Trinidad and Tobago in 1999 to that in 2004?
Offer a terse response. 1.25. What is the ratio of the Number of enrolments of both sexes of Sub-Saharan Africa (developing only) in 1999 to that in 2005?
Your answer should be compact. 0.74. What is the ratio of the Number of enrolments of both sexes in Palau in 1999 to that in 2005?
Offer a very short reply. 1.05. What is the ratio of the Number of enrolments of both sexes in Trinidad and Tobago in 1999 to that in 2005?
Make the answer very short. 1.33. What is the ratio of the Number of enrolments of both sexes in Sub-Saharan Africa (developing only) in 1999 to that in 2007?
Your answer should be very brief. 0.68. What is the ratio of the Number of enrolments of both sexes in Palau in 1999 to that in 2007?
Make the answer very short. 1.23. What is the ratio of the Number of enrolments of both sexes of Tajikistan in 1999 to that in 2007?
Offer a terse response. 1.01. What is the ratio of the Number of enrolments of both sexes in Trinidad and Tobago in 1999 to that in 2007?
Provide a succinct answer. 1.32. What is the ratio of the Number of enrolments of both sexes in Sub-Saharan Africa (developing only) in 2000 to that in 2003?
Your response must be concise. 0.86. What is the ratio of the Number of enrolments of both sexes in Palau in 2000 to that in 2003?
Provide a short and direct response. 0.98. What is the ratio of the Number of enrolments of both sexes in Tajikistan in 2000 to that in 2003?
Make the answer very short. 1. What is the ratio of the Number of enrolments of both sexes of Trinidad and Tobago in 2000 to that in 2003?
Keep it short and to the point. 1.2. What is the ratio of the Number of enrolments of both sexes of Sub-Saharan Africa (developing only) in 2000 to that in 2004?
Offer a terse response. 0.82. What is the ratio of the Number of enrolments of both sexes in Palau in 2000 to that in 2004?
Provide a succinct answer. 1.05. What is the ratio of the Number of enrolments of both sexes of Tajikistan in 2000 to that in 2004?
Offer a very short reply. 1. What is the ratio of the Number of enrolments of both sexes in Trinidad and Tobago in 2000 to that in 2004?
Keep it short and to the point. 1.23. What is the ratio of the Number of enrolments of both sexes in Sub-Saharan Africa (developing only) in 2000 to that in 2005?
Make the answer very short. 0.78. What is the ratio of the Number of enrolments of both sexes of Palau in 2000 to that in 2005?
Ensure brevity in your answer.  1.08. What is the ratio of the Number of enrolments of both sexes of Trinidad and Tobago in 2000 to that in 2005?
Your answer should be compact. 1.3. What is the ratio of the Number of enrolments of both sexes of Sub-Saharan Africa (developing only) in 2000 to that in 2007?
Make the answer very short. 0.71. What is the ratio of the Number of enrolments of both sexes in Palau in 2000 to that in 2007?
Offer a terse response. 1.26. What is the ratio of the Number of enrolments of both sexes of Trinidad and Tobago in 2000 to that in 2007?
Keep it short and to the point. 1.29. What is the ratio of the Number of enrolments of both sexes in Sub-Saharan Africa (developing only) in 2003 to that in 2004?
Your answer should be very brief. 0.95. What is the ratio of the Number of enrolments of both sexes of Palau in 2003 to that in 2004?
Offer a very short reply. 1.07. What is the ratio of the Number of enrolments of both sexes in Tajikistan in 2003 to that in 2004?
Offer a terse response. 1.01. What is the ratio of the Number of enrolments of both sexes of Trinidad and Tobago in 2003 to that in 2004?
Keep it short and to the point. 1.03. What is the ratio of the Number of enrolments of both sexes in Sub-Saharan Africa (developing only) in 2003 to that in 2005?
Keep it short and to the point. 0.9. What is the ratio of the Number of enrolments of both sexes of Palau in 2003 to that in 2005?
Your response must be concise. 1.1. What is the ratio of the Number of enrolments of both sexes of Trinidad and Tobago in 2003 to that in 2005?
Provide a short and direct response. 1.09. What is the ratio of the Number of enrolments of both sexes in Sub-Saharan Africa (developing only) in 2003 to that in 2007?
Your answer should be very brief. 0.83. What is the ratio of the Number of enrolments of both sexes of Palau in 2003 to that in 2007?
Ensure brevity in your answer.  1.29. What is the ratio of the Number of enrolments of both sexes in Tajikistan in 2003 to that in 2007?
Give a very brief answer. 1.02. What is the ratio of the Number of enrolments of both sexes in Trinidad and Tobago in 2003 to that in 2007?
Ensure brevity in your answer.  1.08. What is the ratio of the Number of enrolments of both sexes in Sub-Saharan Africa (developing only) in 2004 to that in 2005?
Make the answer very short. 0.95. What is the ratio of the Number of enrolments of both sexes in Palau in 2004 to that in 2005?
Your answer should be very brief. 1.03. What is the ratio of the Number of enrolments of both sexes of Trinidad and Tobago in 2004 to that in 2005?
Make the answer very short. 1.06. What is the ratio of the Number of enrolments of both sexes in Sub-Saharan Africa (developing only) in 2004 to that in 2007?
Your answer should be very brief. 0.87. What is the ratio of the Number of enrolments of both sexes of Palau in 2004 to that in 2007?
Offer a terse response. 1.2. What is the ratio of the Number of enrolments of both sexes in Tajikistan in 2004 to that in 2007?
Your answer should be very brief. 1.01. What is the ratio of the Number of enrolments of both sexes of Trinidad and Tobago in 2004 to that in 2007?
Keep it short and to the point. 1.05. What is the ratio of the Number of enrolments of both sexes of Sub-Saharan Africa (developing only) in 2005 to that in 2007?
Offer a very short reply. 0.92. What is the ratio of the Number of enrolments of both sexes of Palau in 2005 to that in 2007?
Provide a short and direct response. 1.17. What is the ratio of the Number of enrolments of both sexes of Tajikistan in 2005 to that in 2007?
Keep it short and to the point. 1.02. What is the ratio of the Number of enrolments of both sexes of Trinidad and Tobago in 2005 to that in 2007?
Your answer should be very brief. 1. What is the difference between the highest and the second highest Number of enrolments of both sexes of Sub-Saharan Africa (developing only)?
Provide a succinct answer. 1.06e+07. What is the difference between the highest and the second highest Number of enrolments of both sexes in Tajikistan?
Provide a succinct answer. 1852. What is the difference between the highest and the second highest Number of enrolments of both sexes of Trinidad and Tobago?
Keep it short and to the point. 3672. What is the difference between the highest and the lowest Number of enrolments of both sexes of Sub-Saharan Africa (developing only)?
Make the answer very short. 4.11e+07. What is the difference between the highest and the lowest Number of enrolments of both sexes in Palau?
Your answer should be compact. 441. What is the difference between the highest and the lowest Number of enrolments of both sexes of Tajikistan?
Provide a succinct answer. 1.46e+04. What is the difference between the highest and the lowest Number of enrolments of both sexes of Trinidad and Tobago?
Offer a terse response. 4.25e+04. 